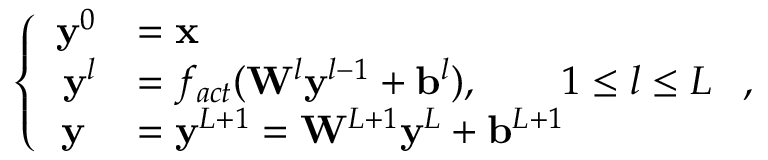Convert formula to latex. <formula><loc_0><loc_0><loc_500><loc_500>\left \{ \begin{array} { r l } { y ^ { 0 } } & { = x } \\ { y ^ { l } } & { = f _ { a c t } ( W ^ { l } y ^ { l - 1 } + b ^ { l } ) , \quad 1 \leq l \leq L } \\ { y \, } & { = y ^ { L + 1 } = W ^ { L + 1 } y ^ { L } + b ^ { L + 1 } } \end{array} ,</formula> 